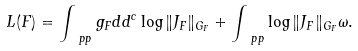<formula> <loc_0><loc_0><loc_500><loc_500>L ( F ) = \int _ { \ p p } g _ { F } d d ^ { c } \log \| { J _ { F } } \| _ { G _ { F } } + \int _ { \ p p } \log \| { J _ { F } } \| _ { G _ { F } } \omega .</formula> 